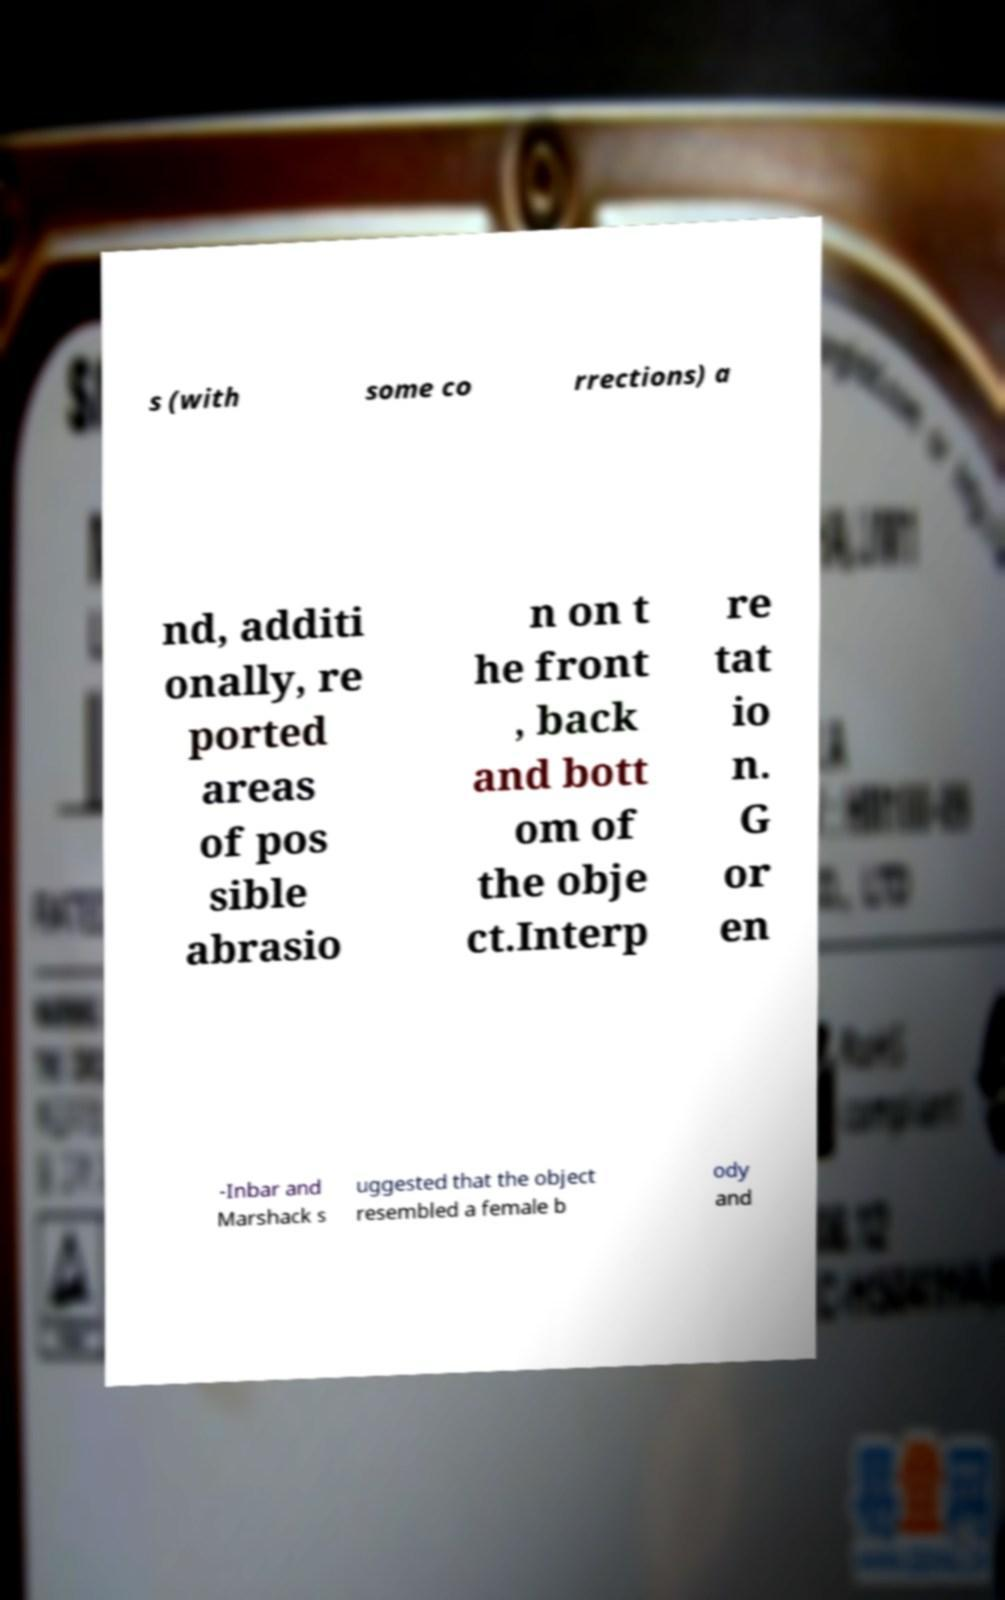Could you extract and type out the text from this image? s (with some co rrections) a nd, additi onally, re ported areas of pos sible abrasio n on t he front , back and bott om of the obje ct.Interp re tat io n. G or en -Inbar and Marshack s uggested that the object resembled a female b ody and 